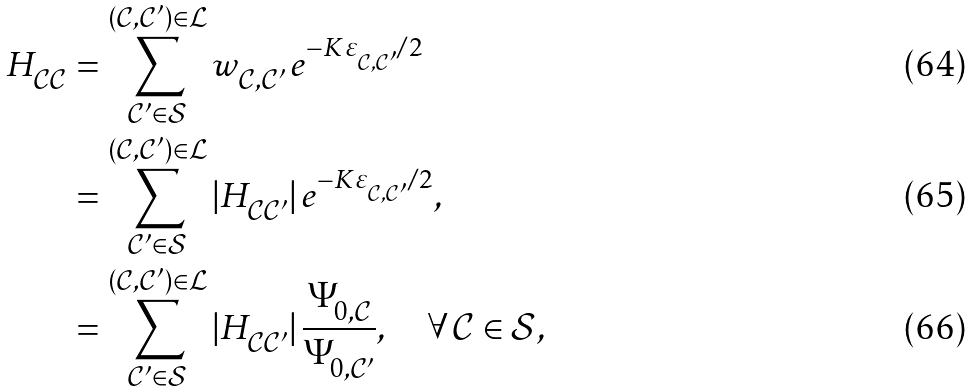Convert formula to latex. <formula><loc_0><loc_0><loc_500><loc_500>H ^ { \ } _ { \mathcal { C } \mathcal { C } } & = \sum _ { \mathcal { C } ^ { \prime } \in \mathcal { S } } ^ { ( \mathcal { C } , \mathcal { C } ^ { \prime } ) \in \mathcal { L } } w ^ { \ } _ { \mathcal { C } , \mathcal { C } ^ { \prime } } \, e ^ { - K \varepsilon ^ { \ } _ { \mathcal { C } , \mathcal { C } ^ { \prime } } / 2 } \\ & = \sum _ { \mathcal { C } ^ { \prime } \in \mathcal { S } } ^ { ( \mathcal { C } , \mathcal { C } ^ { \prime } ) \in \mathcal { L } } | H ^ { \ } _ { \mathcal { C } \mathcal { C } ^ { \prime } } | \, e ^ { - K \varepsilon ^ { \ } _ { \mathcal { C } , \mathcal { C } ^ { \prime } } / 2 } , \\ & = \sum _ { \mathcal { C } ^ { \prime } \in \mathcal { S } } ^ { ( \mathcal { C } , \mathcal { C } ^ { \prime } ) \in \mathcal { L } } | H ^ { \ } _ { \mathcal { C } \mathcal { C } ^ { \prime } } | \, \frac { \Psi ^ { \ } _ { 0 , \mathcal { C } } } { \Psi ^ { \ } _ { 0 , \mathcal { C } ^ { \prime } } } , \quad \forall \, \mathcal { C } \in \mathcal { S } ,</formula> 